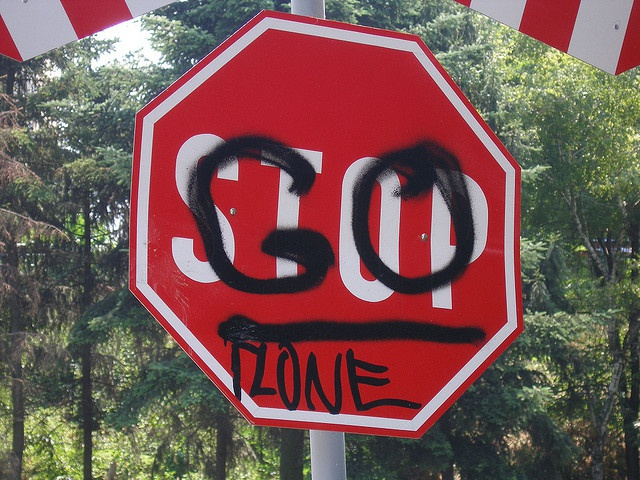Describe the objects in this image and their specific colors. I can see a stop sign in darkgray, brown, black, and lightgray tones in this image. 